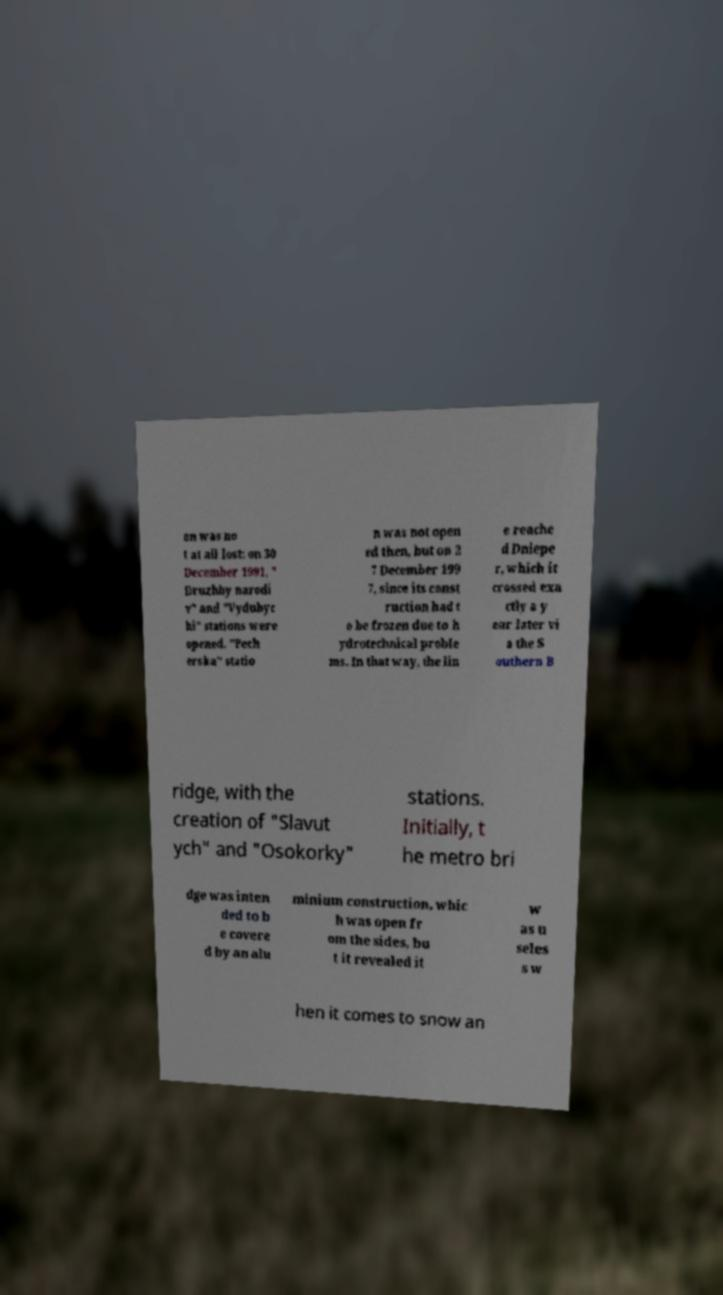What messages or text are displayed in this image? I need them in a readable, typed format. on was no t at all lost: on 30 December 1991, " Druzhby narodi v" and "Vydubyc hi" stations were opened. "Pech erska" statio n was not open ed then, but on 2 7 December 199 7, since its const ruction had t o be frozen due to h ydrotechnical proble ms. In that way, the lin e reache d Dniepe r, which it crossed exa ctly a y ear later vi a the S outhern B ridge, with the creation of "Slavut ych" and "Osokorky" stations. Initially, t he metro bri dge was inten ded to b e covere d by an alu minium construction, whic h was open fr om the sides, bu t it revealed it w as u seles s w hen it comes to snow an 